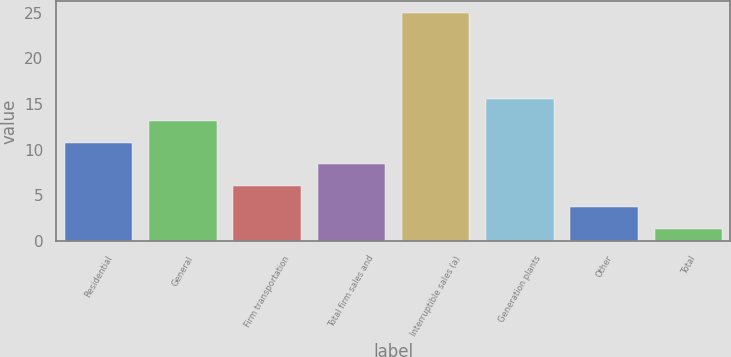Convert chart. <chart><loc_0><loc_0><loc_500><loc_500><bar_chart><fcel>Residential<fcel>General<fcel>Firm transportation<fcel>Total firm sales and<fcel>Interruptible sales (a)<fcel>Generation plants<fcel>Other<fcel>Total<nl><fcel>10.78<fcel>13.15<fcel>6.04<fcel>8.41<fcel>25<fcel>15.52<fcel>3.67<fcel>1.3<nl></chart> 